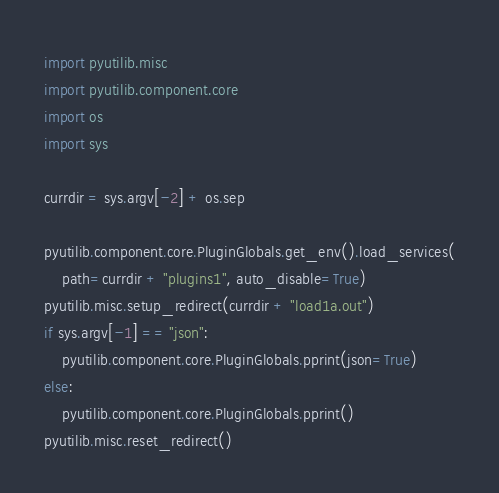<code> <loc_0><loc_0><loc_500><loc_500><_Python_>import pyutilib.misc
import pyutilib.component.core
import os
import sys

currdir = sys.argv[-2] + os.sep

pyutilib.component.core.PluginGlobals.get_env().load_services(
    path=currdir + "plugins1", auto_disable=True)
pyutilib.misc.setup_redirect(currdir + "load1a.out")
if sys.argv[-1] == "json":
    pyutilib.component.core.PluginGlobals.pprint(json=True)
else:
    pyutilib.component.core.PluginGlobals.pprint()
pyutilib.misc.reset_redirect()
</code> 